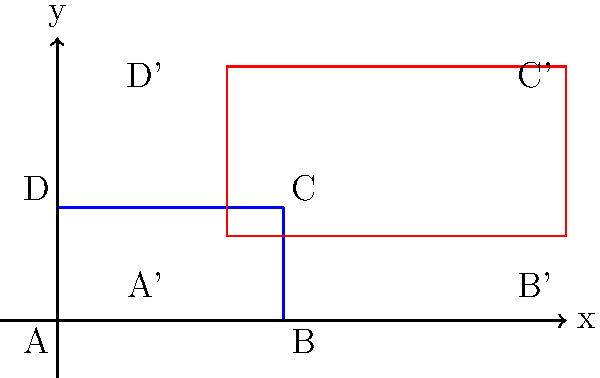As a diplomatic courier, you're studying the layout of an airport terminal for efficient navigation. The original terminal ABCD is represented by the blue rectangle, and a proposed expansion is shown by the red rectangle A'B'C'D'. If the expansion involves scaling the original terminal by a factor of 1.5 and then translating it, what is the vector of translation $\vec{v}$ applied after scaling? Let's approach this step-by-step:

1) First, we need to identify the coordinates of point A before and after the transformation:
   A(0,0) → A'(2,1)

2) The scaling operation is applied first. Scaling by 1.5 would transform A(0,0) to (0,0), as scaling doesn't affect the origin.

3) Therefore, the entire translation must be represented by the vector from (0,0) to (2,1).

4) The translation vector $\vec{v}$ is thus:
   $\vec{v} = \overrightarrow{AA'} = (2-0, 1-0) = (2,1)$

5) We can verify this by checking another point, say B(4,0):
   - After scaling: (4*1.5, 0*1.5) = (6,0)
   - After translation: (6+2, 0+1) = (8,1), which matches B' on the diagram.

Therefore, the translation vector $\vec{v}$ applied after scaling is (2,1).
Answer: $\vec{v} = (2,1)$ 